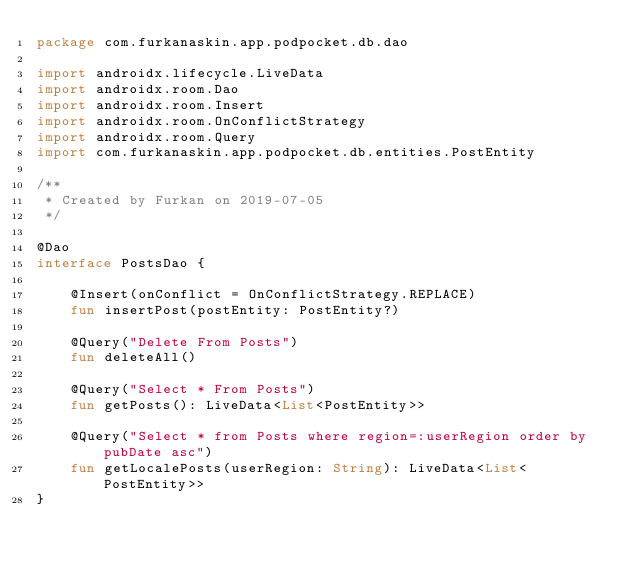Convert code to text. <code><loc_0><loc_0><loc_500><loc_500><_Kotlin_>package com.furkanaskin.app.podpocket.db.dao

import androidx.lifecycle.LiveData
import androidx.room.Dao
import androidx.room.Insert
import androidx.room.OnConflictStrategy
import androidx.room.Query
import com.furkanaskin.app.podpocket.db.entities.PostEntity

/**
 * Created by Furkan on 2019-07-05
 */

@Dao
interface PostsDao {

    @Insert(onConflict = OnConflictStrategy.REPLACE)
    fun insertPost(postEntity: PostEntity?)

    @Query("Delete From Posts")
    fun deleteAll()

    @Query("Select * From Posts")
    fun getPosts(): LiveData<List<PostEntity>>

    @Query("Select * from Posts where region=:userRegion order by pubDate asc")
    fun getLocalePosts(userRegion: String): LiveData<List<PostEntity>>
}</code> 